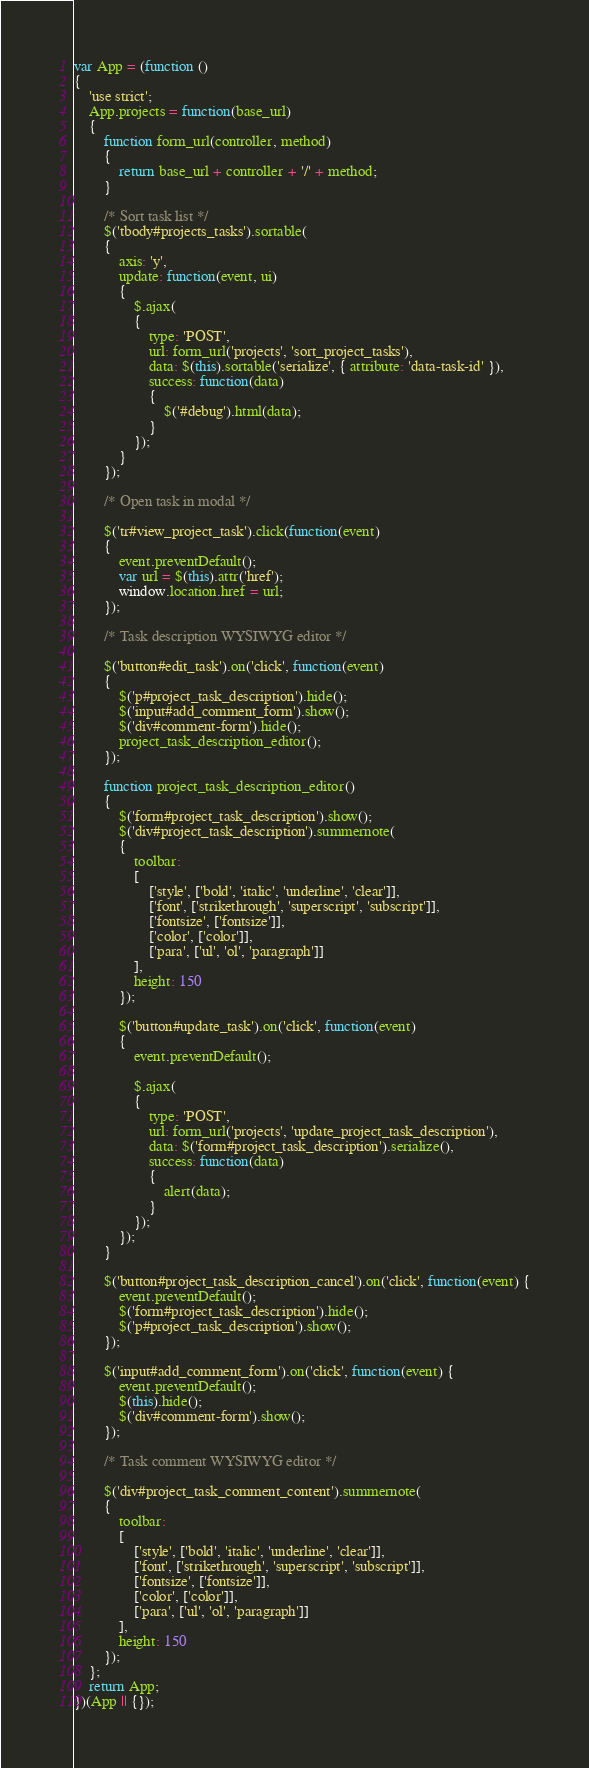Convert code to text. <code><loc_0><loc_0><loc_500><loc_500><_JavaScript_>var App = (function () 
{
	'use strict';
	App.projects = function(base_url)
	{
		function form_url(controller, method)
		{
			return base_url + controller + '/' + method;
		}
		
		/* Sort task list */
		$('tbody#projects_tasks').sortable(
		{
			axis: 'y',
			update: function(event, ui)
			{
				$.ajax(
				{
					type: 'POST',
					url: form_url('projects', 'sort_project_tasks'),
					data: $(this).sortable('serialize', { attribute: 'data-task-id' }),
					success: function(data)
					{
						$('#debug').html(data);
					}
				});
			}
		});
		
		/* Open task in modal */
		
		$('tr#view_project_task').click(function(event)
		{
			event.preventDefault();
			var url = $(this).attr('href');
			window.location.href = url;
		});
		
		/* Task description WYSIWYG editor */
		
		$('button#edit_task').on('click', function(event)
		{
			$('p#project_task_description').hide();
			$('input#add_comment_form').show();
			$('div#comment-form').hide();
			project_task_description_editor();
		});
		
		function project_task_description_editor()
		{
			$('form#project_task_description').show();
			$('div#project_task_description').summernote(
			{
				toolbar: 
				[
					['style', ['bold', 'italic', 'underline', 'clear']],
					['font', ['strikethrough', 'superscript', 'subscript']],
					['fontsize', ['fontsize']],
					['color', ['color']],
					['para', ['ul', 'ol', 'paragraph']]
				],
				height: 150
			});
			
			$('button#update_task').on('click', function(event)
			{
				event.preventDefault();
				
				$.ajax(
				{
					type: 'POST',
					url: form_url('projects', 'update_project_task_description'),
					data: $('form#project_task_description').serialize(),
					success: function(data)
					{
						alert(data);
					}
				});
			});
		}
		
		$('button#project_task_description_cancel').on('click', function(event) {
			event.preventDefault();
			$('form#project_task_description').hide();
			$('p#project_task_description').show();
		});
		
		$('input#add_comment_form').on('click', function(event) {
			event.preventDefault();
			$(this).hide();
			$('div#comment-form').show();
		});
		
		/* Task comment WYSIWYG editor */
		
		$('div#project_task_comment_content').summernote(
		{
			toolbar: 
			[
				['style', ['bold', 'italic', 'underline', 'clear']],
				['font', ['strikethrough', 'superscript', 'subscript']],
				['fontsize', ['fontsize']],
				['color', ['color']],
				['para', ['ul', 'ol', 'paragraph']]
			],
			height: 150
		});
	};
	return App;
})(App || {});</code> 